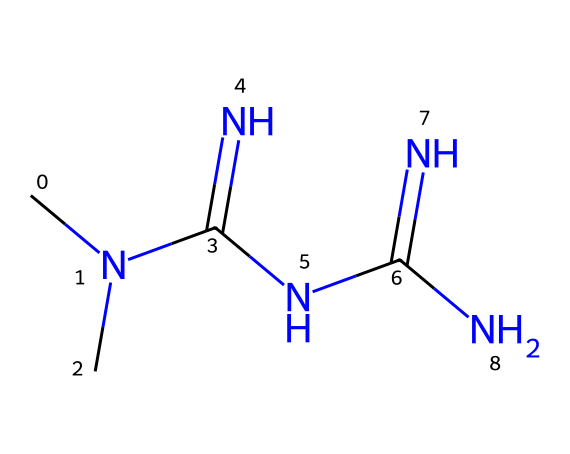How many nitrogen atoms are present in the structure of metformin? To determine the number of nitrogen atoms, we can count the N symbols in the SMILES representation CN(C)C(=N)NC(=N)N. There are four nitrogen atoms: two in the middle (C(=N)N), one on the left (CN), and one in the right (C(=N)N).
Answer: four What is the molecular formula of metformin based on its structure? The molecular formula can be derived from the SMILES representation by identifying the constituent atoms: there are three carbon atoms (C), seven hydrogen atoms (H), and four nitrogen atoms (N). Therefore, the molecular formula is C4H11N5.
Answer: C4H11N5 Does metformin contain any carbon-carbon double bonds? The structure can be analyzed from the SMILES. In metformin, there are no double bonds between carbon atoms; the only double bond present is between carbon and nitrogen in the C(=N)N sections.
Answer: no How does the presence of multiple nitrogen atoms affect the solubility of metformin? Nitrogen atoms have polar characteristics that contribute to hydrogen bonding with water, which enhances the solubility of metformin in aqueous solutions. Since there are multiple nitrogen atoms, this increases its overall polarity.
Answer: increases solubility What type of functional groups are present in metformin? By analyzing the SMILES structure, we see amine (NH2) groups and an amidine functional group (C(=N)N). The presence of these functional groups is significant for its pharmacological properties.
Answer: amine and amidine Is metformin considered a polar or non-polar compound? The presence of multiple nitrogen atoms and the structural configuration, including polar functional groups, indicates that metformin is polar. Polar compounds typically have a significant electronegativity, promoting interactions with water.
Answer: polar 